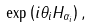<formula> <loc_0><loc_0><loc_500><loc_500>\exp \left ( i \theta _ { i } H _ { \alpha _ { i } } \right ) ,</formula> 